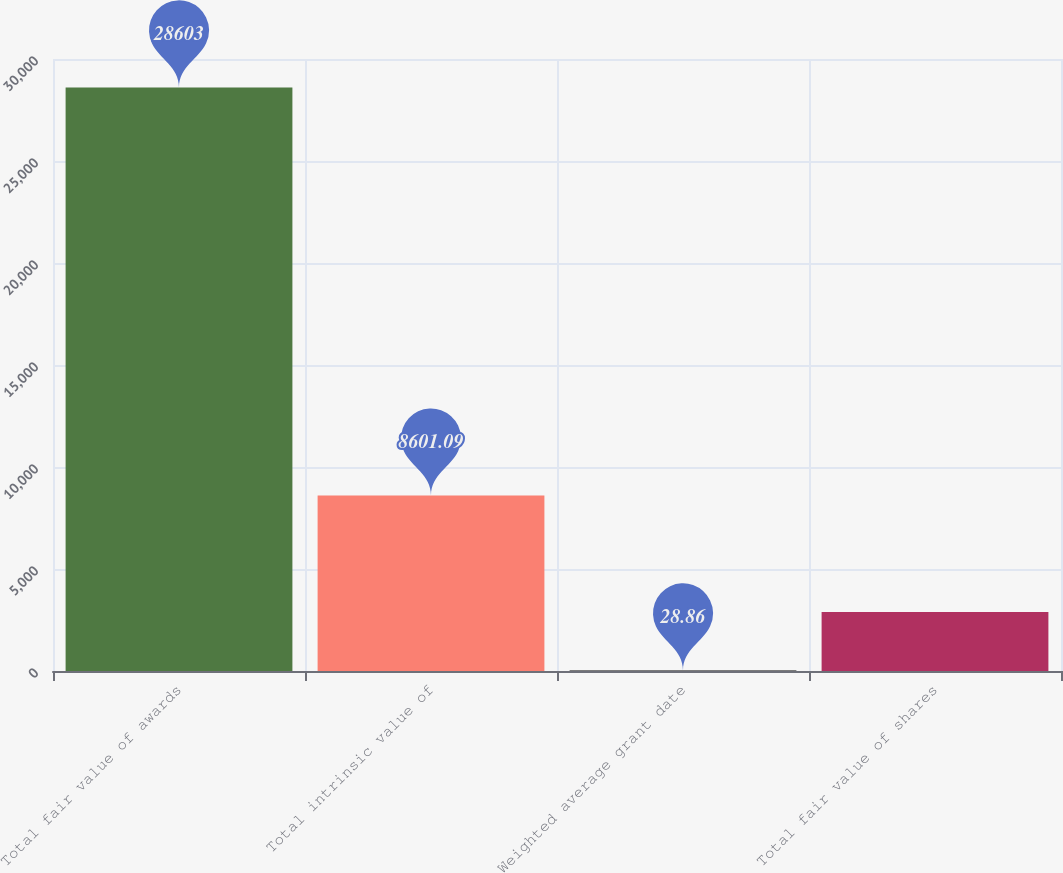Convert chart to OTSL. <chart><loc_0><loc_0><loc_500><loc_500><bar_chart><fcel>Total fair value of awards<fcel>Total intrinsic value of<fcel>Weighted average grant date<fcel>Total fair value of shares<nl><fcel>28603<fcel>8601.09<fcel>28.86<fcel>2886.27<nl></chart> 